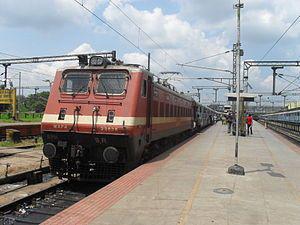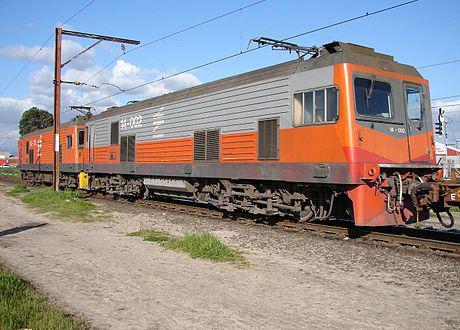The first image is the image on the left, the second image is the image on the right. For the images displayed, is the sentence "In one image, an orange and yellow locomotive has steps and white hand rails leading to a small yellow platform." factually correct? Answer yes or no. No. The first image is the image on the left, the second image is the image on the right. For the images shown, is this caption "The trains in the left and right images appear to be headed toward each other, so they would collide." true? Answer yes or no. No. 